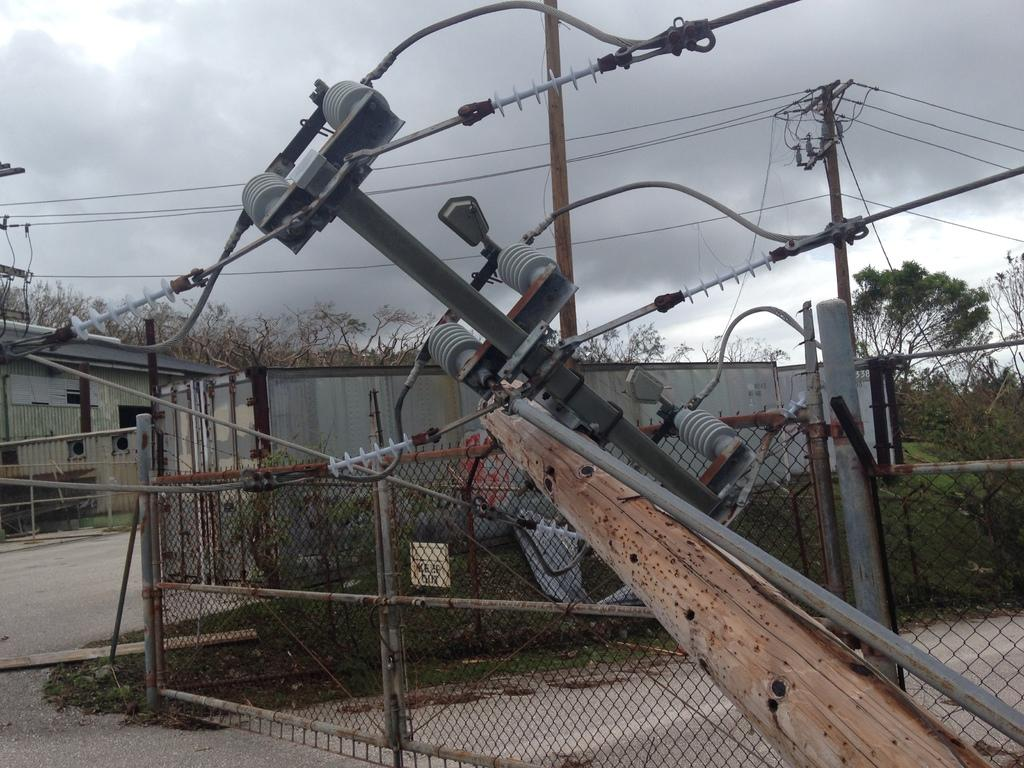What is located in the center of the image? There is an electric pole and a wooden log in the center of the image. What can be seen in the background of the image? There is a fence, sheds, trees, wires, poles, and the sky visible in the background of the image. What type of comb is being used to solve the riddle in the image? There is no comb or riddle present in the image. 